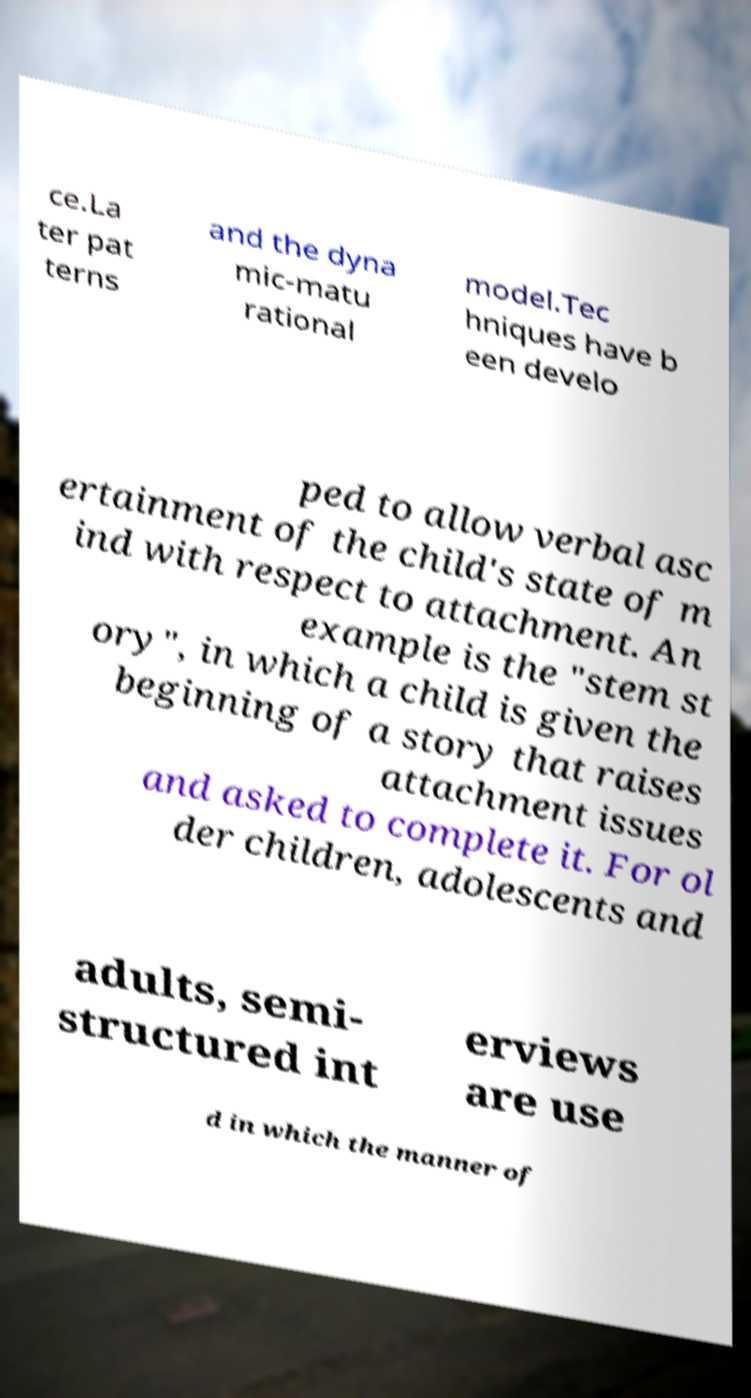Please identify and transcribe the text found in this image. ce.La ter pat terns and the dyna mic-matu rational model.Tec hniques have b een develo ped to allow verbal asc ertainment of the child's state of m ind with respect to attachment. An example is the "stem st ory", in which a child is given the beginning of a story that raises attachment issues and asked to complete it. For ol der children, adolescents and adults, semi- structured int erviews are use d in which the manner of 